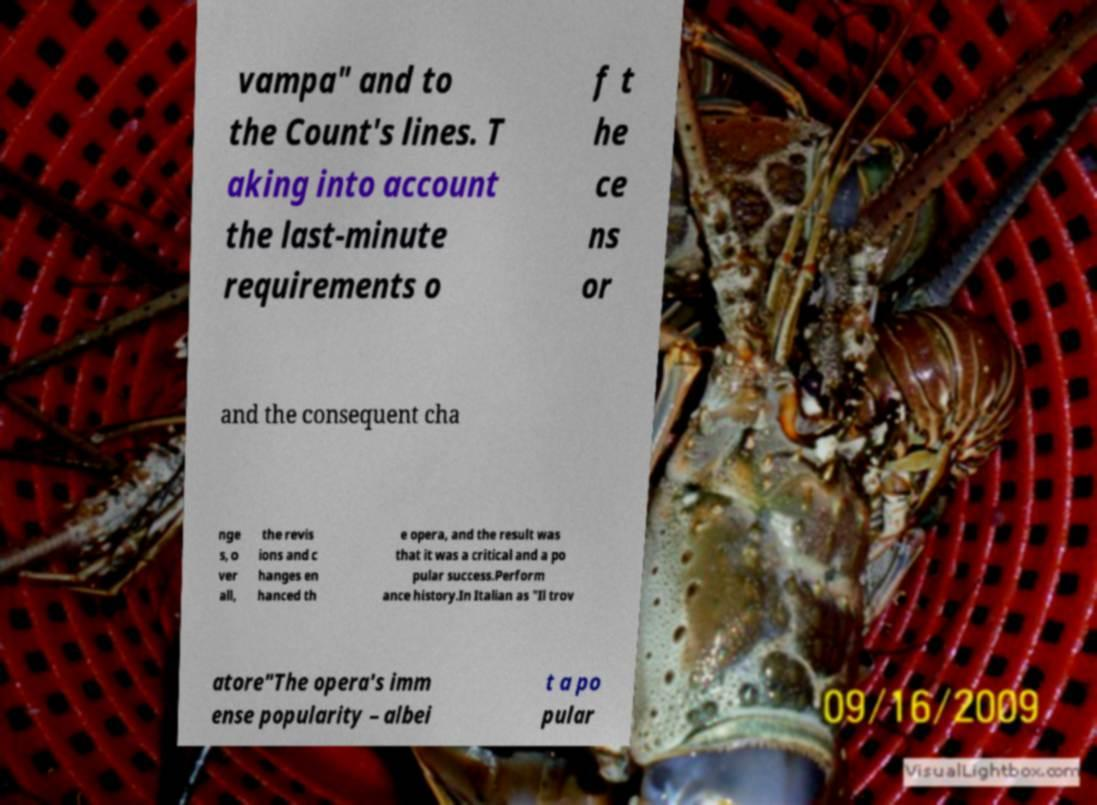For documentation purposes, I need the text within this image transcribed. Could you provide that? vampa" and to the Count's lines. T aking into account the last-minute requirements o f t he ce ns or and the consequent cha nge s, o ver all, the revis ions and c hanges en hanced th e opera, and the result was that it was a critical and a po pular success.Perform ance history.In Italian as "Il trov atore"The opera's imm ense popularity – albei t a po pular 